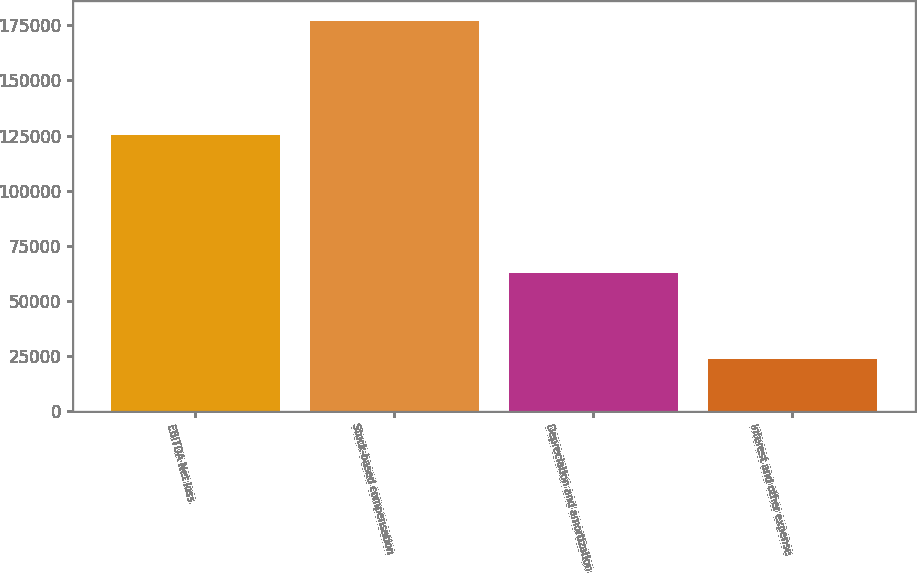<chart> <loc_0><loc_0><loc_500><loc_500><bar_chart><fcel>EBITDA Net loss<fcel>Stock-based compensation<fcel>Depreciation and amortization<fcel>Interest and other expense<nl><fcel>125352<fcel>177215<fcel>62428<fcel>23512<nl></chart> 